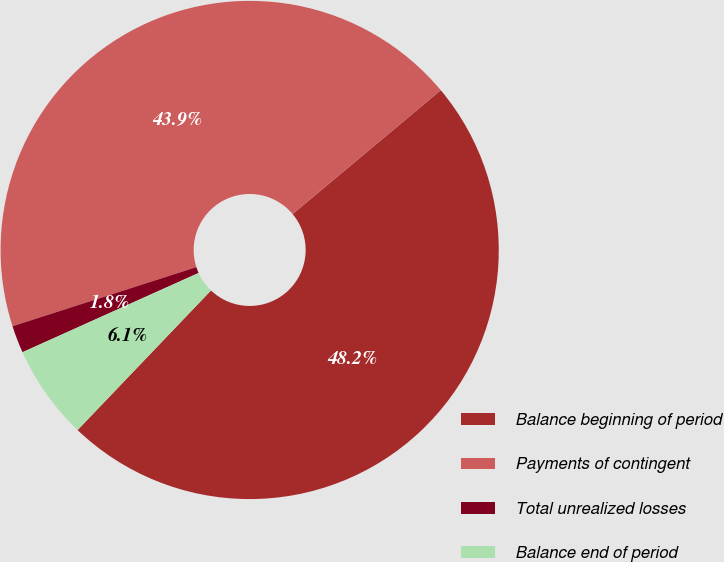Convert chart. <chart><loc_0><loc_0><loc_500><loc_500><pie_chart><fcel>Balance beginning of period<fcel>Payments of contingent<fcel>Total unrealized losses<fcel>Balance end of period<nl><fcel>48.22%<fcel>43.87%<fcel>1.78%<fcel>6.13%<nl></chart> 